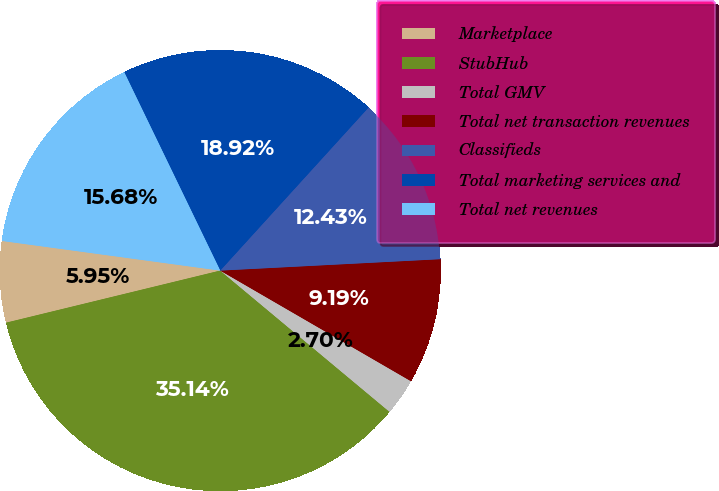<chart> <loc_0><loc_0><loc_500><loc_500><pie_chart><fcel>Marketplace<fcel>StubHub<fcel>Total GMV<fcel>Total net transaction revenues<fcel>Classifieds<fcel>Total marketing services and<fcel>Total net revenues<nl><fcel>5.95%<fcel>35.14%<fcel>2.7%<fcel>9.19%<fcel>12.43%<fcel>18.92%<fcel>15.68%<nl></chart> 